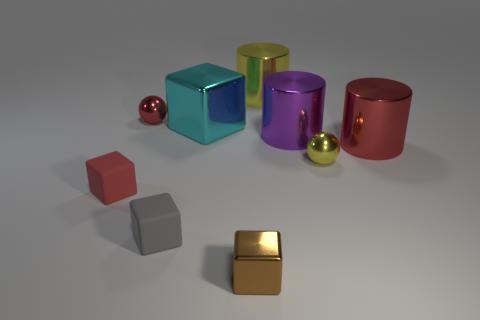What is the shape of the small gray matte thing?
Your answer should be compact. Cube. There is a large thing on the left side of the brown metallic cube in front of the small red metal sphere; what is its color?
Your answer should be very brief. Cyan. Do the large cube and the shiny ball that is to the left of the big yellow metallic thing have the same color?
Your response must be concise. No. The red object that is both in front of the large purple thing and left of the brown cube is made of what material?
Keep it short and to the point. Rubber. Is there a gray matte thing of the same size as the red matte object?
Make the answer very short. Yes. What is the material of the gray thing that is the same size as the brown block?
Ensure brevity in your answer.  Rubber. What number of small shiny things are behind the tiny red block?
Provide a short and direct response. 2. Does the yellow object on the left side of the yellow ball have the same shape as the large purple thing?
Your answer should be very brief. Yes. Are there any gray metal things of the same shape as the tiny red rubber object?
Your answer should be very brief. No. What shape is the large shiny object to the left of the big cylinder behind the large purple cylinder?
Offer a terse response. Cube. 